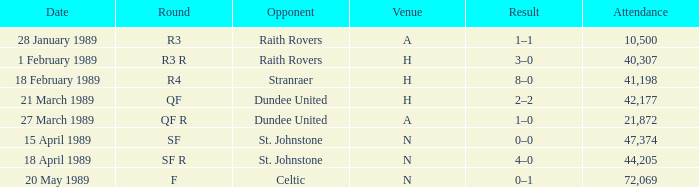What is the date when the rotation is sf? 15 April 1989. 